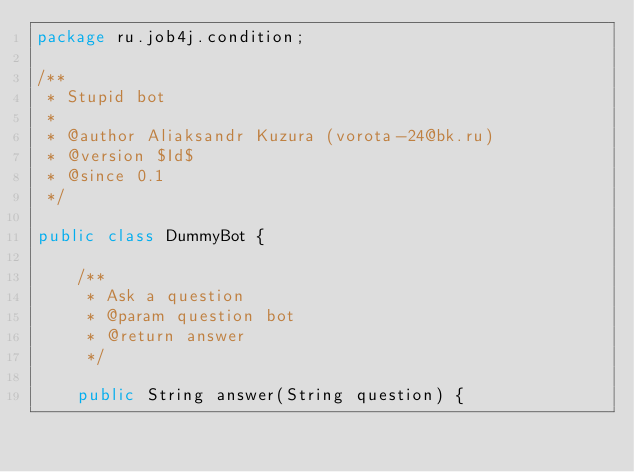<code> <loc_0><loc_0><loc_500><loc_500><_Java_>package ru.job4j.condition;

/**
 * Stupid bot
 *
 * @author Aliaksandr Kuzura (vorota-24@bk.ru)
 * @version $Id$
 * @since 0.1
 */

public class DummyBot {

    /**
     * Ask a question
     * @param question bot
     * @return answer
     */

    public String answer(String question) {</code> 